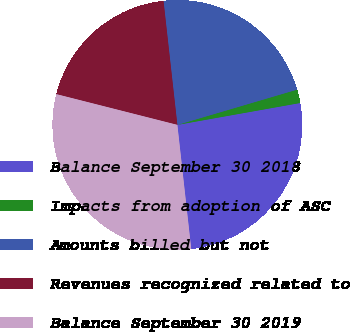<chart> <loc_0><loc_0><loc_500><loc_500><pie_chart><fcel>Balance September 30 2018<fcel>Impacts from adoption of ASC<fcel>Amounts billed but not<fcel>Revenues recognized related to<fcel>Balance September 30 2019<nl><fcel>26.04%<fcel>1.75%<fcel>22.21%<fcel>19.27%<fcel>30.73%<nl></chart> 